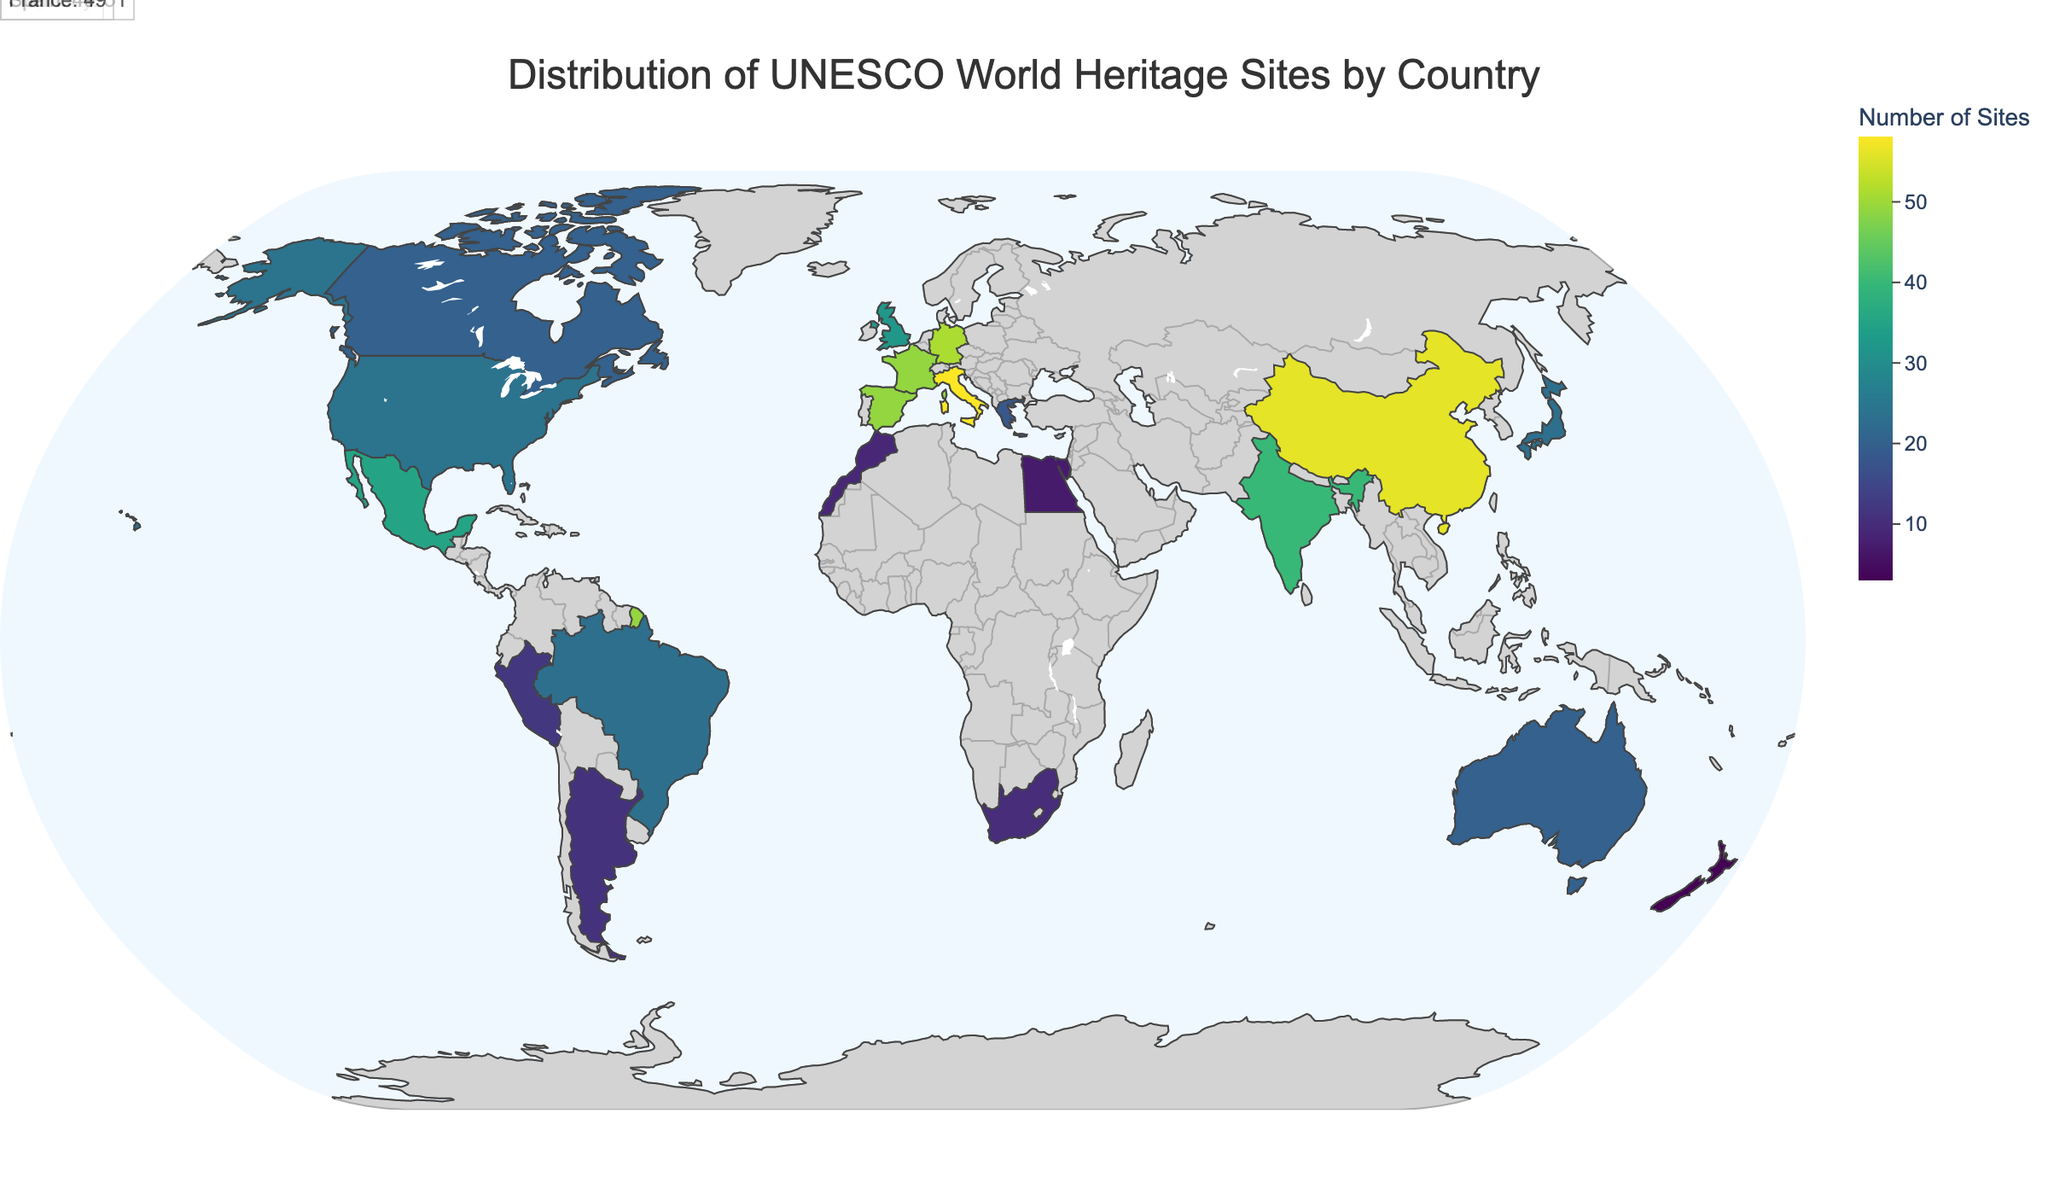What's the title of the plot? The title of the plot is usually placed at the top center of the figure. It summarizes what the figure is about in a concise manner.
Answer: Distribution of UNESCO World Heritage Sites by Country Which country in Europe has the most UNESCO World Heritage Sites? By looking at the annotations and color intensities for European countries, the country with the highest number of UNESCO World Heritage Sites in Europe is visible.
Answer: Italy How many UNESCO World Heritage Sites does China have? China’s number of UNESCO World Heritage Sites can be found by hovering over China on the map or reading its annotation directly.
Answer: 56 Which continent has the least number of UNESCO World Heritage Sites? By observing the color gradients and individual country data points along with their geographic distribution, the continent with the least total number of sites can be identified.
Answer: Oceania Compare the number of UNESCO World Heritage Sites between the United States and Brazil. To compare the numbers, look at the color intensity and hover information of the two countries. The United States and Brazil have their specific values displayed when hovered over.
Answer: United States: 24, Brazil: 23 What is the sum of UNESCO World Heritage Sites in the top 5 countries? Identify the top 5 countries from the annotations, then add their site numbers together. The top 5 countries are Italy (58), China (56), Germany (51), Spain (49), and France (49). Sum = 58 + 56 + 51 + 49 + 49 = 263.
Answer: 263 Which country has more UNESCO World Heritage Sites, India or Japan? Compare the numbers directly by looking at the numerical values shown for India and Japan.
Answer: India What is the approximate color of countries with more than 50 UNESCO World Heritage Sites? Identify the countries with more than 50 sites and observe their color shade in the choropleth map. These countries will have an intense or darker shade corresponding to higher values.
Answer: Darker Green Name two African countries with their number of UNESCO World Heritage Sites listed in the plot. Look at the part of the map referring to Africa and read the annotations or hover information. Two countries listed include South Africa and Morocco.
Answer: South Africa: 10, Morocco: 9 Identify a country in Oceania that has a low number of UNESCO World Heritage Sites and specify the number. By observing the region of Oceania, primarily focusing on color shades and annotations, the country with a low number of sites can be identified.
Answer: New Zealand, 3 